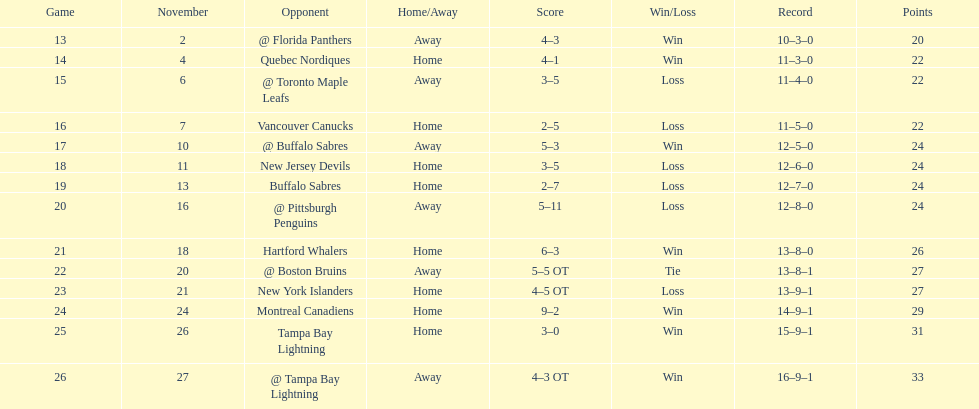The 1993-1994 flyers missed the playoffs again. how many consecutive seasons up until 93-94 did the flyers miss the playoffs? 5. 